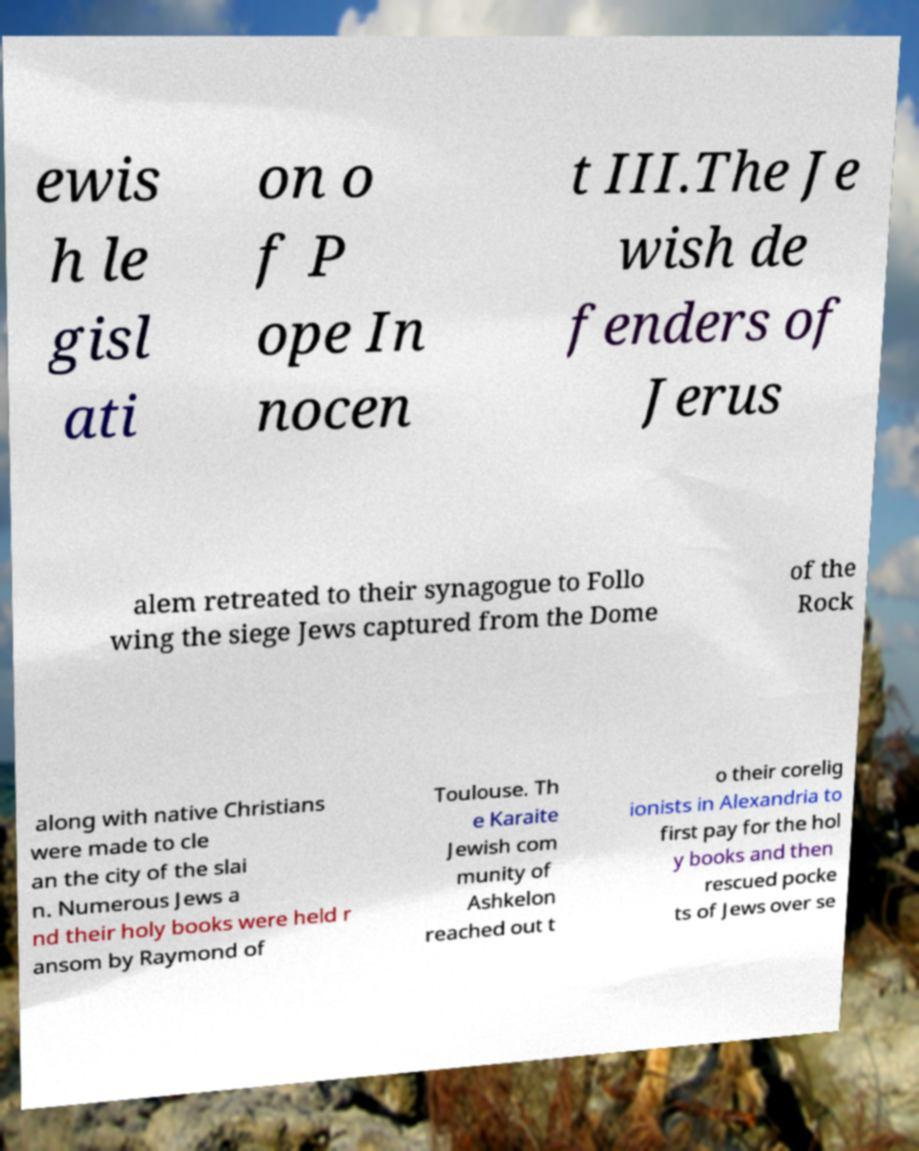Could you extract and type out the text from this image? ewis h le gisl ati on o f P ope In nocen t III.The Je wish de fenders of Jerus alem retreated to their synagogue to Follo wing the siege Jews captured from the Dome of the Rock along with native Christians were made to cle an the city of the slai n. Numerous Jews a nd their holy books were held r ansom by Raymond of Toulouse. Th e Karaite Jewish com munity of Ashkelon reached out t o their corelig ionists in Alexandria to first pay for the hol y books and then rescued pocke ts of Jews over se 